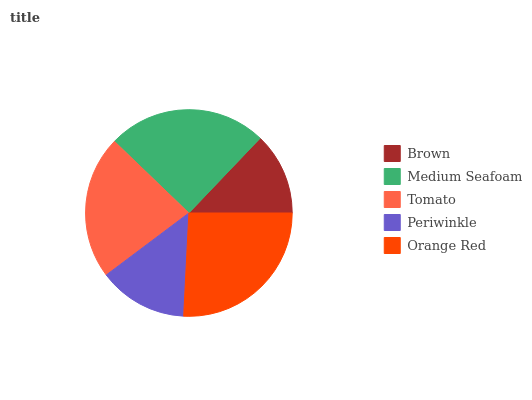Is Brown the minimum?
Answer yes or no. Yes. Is Orange Red the maximum?
Answer yes or no. Yes. Is Medium Seafoam the minimum?
Answer yes or no. No. Is Medium Seafoam the maximum?
Answer yes or no. No. Is Medium Seafoam greater than Brown?
Answer yes or no. Yes. Is Brown less than Medium Seafoam?
Answer yes or no. Yes. Is Brown greater than Medium Seafoam?
Answer yes or no. No. Is Medium Seafoam less than Brown?
Answer yes or no. No. Is Tomato the high median?
Answer yes or no. Yes. Is Tomato the low median?
Answer yes or no. Yes. Is Brown the high median?
Answer yes or no. No. Is Medium Seafoam the low median?
Answer yes or no. No. 